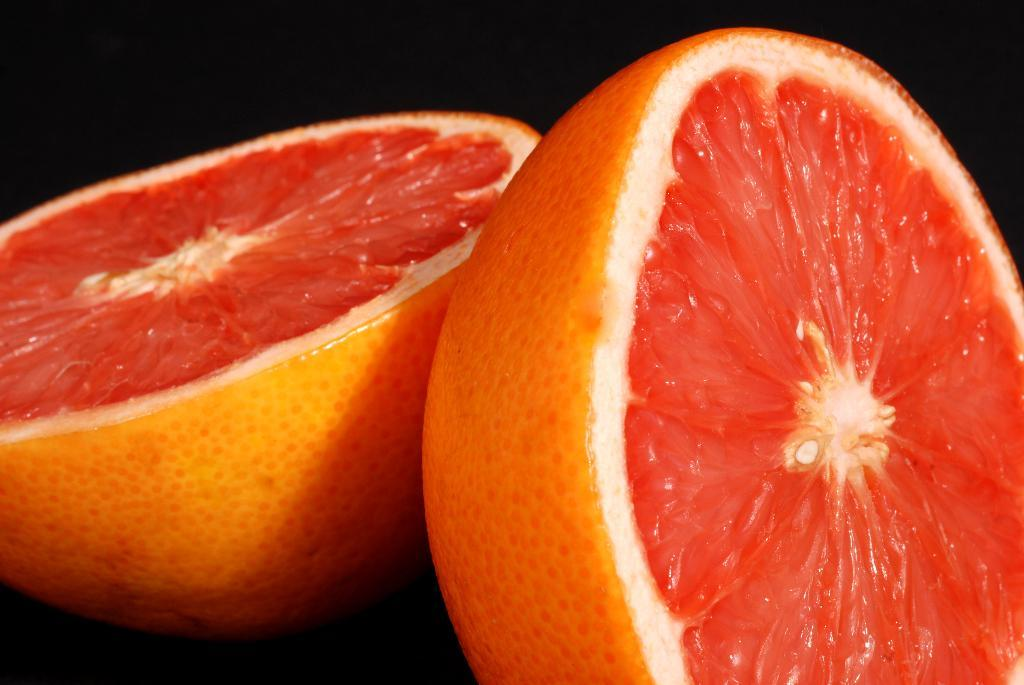What type of fruit is visible in the image? There is an orange sliced into two pieces in the image. How is the orange presented in the image? The orange is sliced into two pieces. What type of map is hidden inside the orange in the image? There is no map present inside the orange in the image; it is simply a sliced orange. 